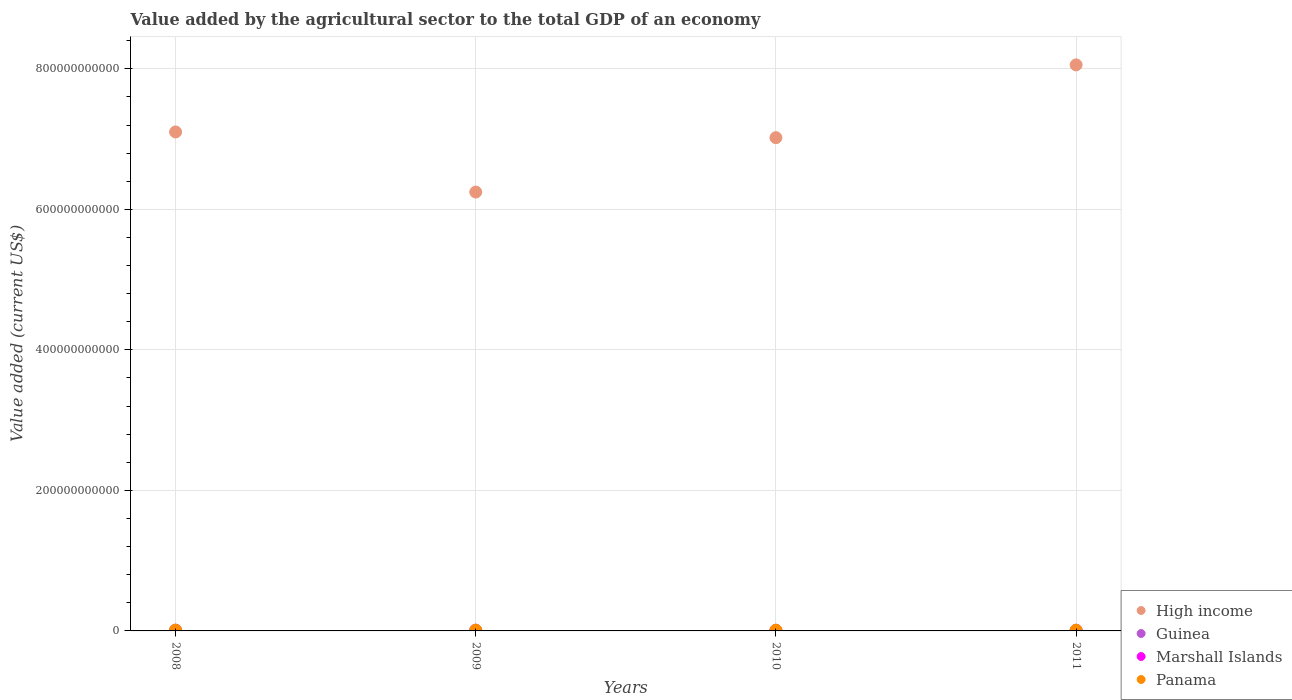Is the number of dotlines equal to the number of legend labels?
Provide a succinct answer. Yes. What is the value added by the agricultural sector to the total GDP in Marshall Islands in 2009?
Your response must be concise. 1.87e+07. Across all years, what is the maximum value added by the agricultural sector to the total GDP in Guinea?
Offer a very short reply. 1.09e+09. Across all years, what is the minimum value added by the agricultural sector to the total GDP in Panama?
Keep it short and to the point. 9.81e+08. What is the total value added by the agricultural sector to the total GDP in Marshall Islands in the graph?
Ensure brevity in your answer.  8.48e+07. What is the difference between the value added by the agricultural sector to the total GDP in Guinea in 2010 and that in 2011?
Give a very brief answer. -6.84e+07. What is the difference between the value added by the agricultural sector to the total GDP in Marshall Islands in 2011 and the value added by the agricultural sector to the total GDP in High income in 2010?
Keep it short and to the point. -7.02e+11. What is the average value added by the agricultural sector to the total GDP in Panama per year?
Provide a succinct answer. 1.04e+09. In the year 2008, what is the difference between the value added by the agricultural sector to the total GDP in Guinea and value added by the agricultural sector to the total GDP in Marshall Islands?
Your answer should be very brief. 1.01e+09. In how many years, is the value added by the agricultural sector to the total GDP in Marshall Islands greater than 560000000000 US$?
Your answer should be very brief. 0. What is the ratio of the value added by the agricultural sector to the total GDP in High income in 2008 to that in 2009?
Ensure brevity in your answer.  1.14. Is the value added by the agricultural sector to the total GDP in Marshall Islands in 2009 less than that in 2010?
Provide a succinct answer. Yes. What is the difference between the highest and the second highest value added by the agricultural sector to the total GDP in High income?
Provide a short and direct response. 9.55e+1. What is the difference between the highest and the lowest value added by the agricultural sector to the total GDP in High income?
Offer a very short reply. 1.81e+11. Is it the case that in every year, the sum of the value added by the agricultural sector to the total GDP in Marshall Islands and value added by the agricultural sector to the total GDP in Panama  is greater than the sum of value added by the agricultural sector to the total GDP in Guinea and value added by the agricultural sector to the total GDP in High income?
Your answer should be very brief. Yes. Is it the case that in every year, the sum of the value added by the agricultural sector to the total GDP in Guinea and value added by the agricultural sector to the total GDP in Panama  is greater than the value added by the agricultural sector to the total GDP in High income?
Offer a very short reply. No. How many dotlines are there?
Make the answer very short. 4. What is the difference between two consecutive major ticks on the Y-axis?
Your response must be concise. 2.00e+11. Are the values on the major ticks of Y-axis written in scientific E-notation?
Ensure brevity in your answer.  No. Does the graph contain any zero values?
Provide a short and direct response. No. Does the graph contain grids?
Offer a terse response. Yes. Where does the legend appear in the graph?
Your answer should be compact. Bottom right. How many legend labels are there?
Give a very brief answer. 4. What is the title of the graph?
Offer a terse response. Value added by the agricultural sector to the total GDP of an economy. What is the label or title of the X-axis?
Provide a succinct answer. Years. What is the label or title of the Y-axis?
Your response must be concise. Value added (current US$). What is the Value added (current US$) of High income in 2008?
Offer a terse response. 7.10e+11. What is the Value added (current US$) in Guinea in 2008?
Provide a short and direct response. 1.03e+09. What is the Value added (current US$) of Marshall Islands in 2008?
Your answer should be compact. 1.54e+07. What is the Value added (current US$) of Panama in 2008?
Offer a very short reply. 1.11e+09. What is the Value added (current US$) in High income in 2009?
Give a very brief answer. 6.25e+11. What is the Value added (current US$) of Guinea in 2009?
Offer a terse response. 1.09e+09. What is the Value added (current US$) in Marshall Islands in 2009?
Offer a very short reply. 1.87e+07. What is the Value added (current US$) of Panama in 2009?
Provide a short and direct response. 1.05e+09. What is the Value added (current US$) of High income in 2010?
Offer a very short reply. 7.02e+11. What is the Value added (current US$) in Guinea in 2010?
Provide a short and direct response. 9.59e+08. What is the Value added (current US$) of Marshall Islands in 2010?
Make the answer very short. 2.42e+07. What is the Value added (current US$) of Panama in 2010?
Provide a succinct answer. 9.81e+08. What is the Value added (current US$) in High income in 2011?
Keep it short and to the point. 8.06e+11. What is the Value added (current US$) in Guinea in 2011?
Provide a short and direct response. 1.03e+09. What is the Value added (current US$) of Marshall Islands in 2011?
Keep it short and to the point. 2.65e+07. What is the Value added (current US$) in Panama in 2011?
Provide a succinct answer. 1.01e+09. Across all years, what is the maximum Value added (current US$) in High income?
Keep it short and to the point. 8.06e+11. Across all years, what is the maximum Value added (current US$) in Guinea?
Your response must be concise. 1.09e+09. Across all years, what is the maximum Value added (current US$) in Marshall Islands?
Make the answer very short. 2.65e+07. Across all years, what is the maximum Value added (current US$) in Panama?
Ensure brevity in your answer.  1.11e+09. Across all years, what is the minimum Value added (current US$) of High income?
Keep it short and to the point. 6.25e+11. Across all years, what is the minimum Value added (current US$) in Guinea?
Make the answer very short. 9.59e+08. Across all years, what is the minimum Value added (current US$) in Marshall Islands?
Offer a very short reply. 1.54e+07. Across all years, what is the minimum Value added (current US$) of Panama?
Your response must be concise. 9.81e+08. What is the total Value added (current US$) of High income in the graph?
Your answer should be compact. 2.84e+12. What is the total Value added (current US$) in Guinea in the graph?
Make the answer very short. 4.11e+09. What is the total Value added (current US$) in Marshall Islands in the graph?
Your response must be concise. 8.48e+07. What is the total Value added (current US$) of Panama in the graph?
Your response must be concise. 4.15e+09. What is the difference between the Value added (current US$) in High income in 2008 and that in 2009?
Provide a succinct answer. 8.55e+1. What is the difference between the Value added (current US$) of Guinea in 2008 and that in 2009?
Give a very brief answer. -5.95e+07. What is the difference between the Value added (current US$) in Marshall Islands in 2008 and that in 2009?
Ensure brevity in your answer.  -3.39e+06. What is the difference between the Value added (current US$) in Panama in 2008 and that in 2009?
Keep it short and to the point. 5.31e+07. What is the difference between the Value added (current US$) of High income in 2008 and that in 2010?
Ensure brevity in your answer.  8.11e+09. What is the difference between the Value added (current US$) of Guinea in 2008 and that in 2010?
Give a very brief answer. 7.14e+07. What is the difference between the Value added (current US$) of Marshall Islands in 2008 and that in 2010?
Your response must be concise. -8.84e+06. What is the difference between the Value added (current US$) in Panama in 2008 and that in 2010?
Your answer should be very brief. 1.25e+08. What is the difference between the Value added (current US$) in High income in 2008 and that in 2011?
Offer a terse response. -9.55e+1. What is the difference between the Value added (current US$) in Guinea in 2008 and that in 2011?
Offer a terse response. 3.08e+06. What is the difference between the Value added (current US$) of Marshall Islands in 2008 and that in 2011?
Ensure brevity in your answer.  -1.11e+07. What is the difference between the Value added (current US$) of Panama in 2008 and that in 2011?
Your answer should be very brief. 9.89e+07. What is the difference between the Value added (current US$) of High income in 2009 and that in 2010?
Your answer should be compact. -7.74e+1. What is the difference between the Value added (current US$) in Guinea in 2009 and that in 2010?
Your response must be concise. 1.31e+08. What is the difference between the Value added (current US$) of Marshall Islands in 2009 and that in 2010?
Provide a short and direct response. -5.46e+06. What is the difference between the Value added (current US$) of Panama in 2009 and that in 2010?
Your response must be concise. 7.22e+07. What is the difference between the Value added (current US$) of High income in 2009 and that in 2011?
Provide a short and direct response. -1.81e+11. What is the difference between the Value added (current US$) in Guinea in 2009 and that in 2011?
Make the answer very short. 6.25e+07. What is the difference between the Value added (current US$) in Marshall Islands in 2009 and that in 2011?
Make the answer very short. -7.71e+06. What is the difference between the Value added (current US$) in Panama in 2009 and that in 2011?
Make the answer very short. 4.58e+07. What is the difference between the Value added (current US$) in High income in 2010 and that in 2011?
Give a very brief answer. -1.04e+11. What is the difference between the Value added (current US$) of Guinea in 2010 and that in 2011?
Provide a short and direct response. -6.84e+07. What is the difference between the Value added (current US$) in Marshall Islands in 2010 and that in 2011?
Provide a succinct answer. -2.25e+06. What is the difference between the Value added (current US$) in Panama in 2010 and that in 2011?
Give a very brief answer. -2.64e+07. What is the difference between the Value added (current US$) of High income in 2008 and the Value added (current US$) of Guinea in 2009?
Make the answer very short. 7.09e+11. What is the difference between the Value added (current US$) of High income in 2008 and the Value added (current US$) of Marshall Islands in 2009?
Make the answer very short. 7.10e+11. What is the difference between the Value added (current US$) of High income in 2008 and the Value added (current US$) of Panama in 2009?
Your answer should be compact. 7.09e+11. What is the difference between the Value added (current US$) in Guinea in 2008 and the Value added (current US$) in Marshall Islands in 2009?
Your response must be concise. 1.01e+09. What is the difference between the Value added (current US$) of Guinea in 2008 and the Value added (current US$) of Panama in 2009?
Your answer should be very brief. -2.32e+07. What is the difference between the Value added (current US$) of Marshall Islands in 2008 and the Value added (current US$) of Panama in 2009?
Your answer should be compact. -1.04e+09. What is the difference between the Value added (current US$) in High income in 2008 and the Value added (current US$) in Guinea in 2010?
Your response must be concise. 7.09e+11. What is the difference between the Value added (current US$) of High income in 2008 and the Value added (current US$) of Marshall Islands in 2010?
Make the answer very short. 7.10e+11. What is the difference between the Value added (current US$) of High income in 2008 and the Value added (current US$) of Panama in 2010?
Ensure brevity in your answer.  7.09e+11. What is the difference between the Value added (current US$) of Guinea in 2008 and the Value added (current US$) of Marshall Islands in 2010?
Make the answer very short. 1.01e+09. What is the difference between the Value added (current US$) of Guinea in 2008 and the Value added (current US$) of Panama in 2010?
Keep it short and to the point. 4.90e+07. What is the difference between the Value added (current US$) in Marshall Islands in 2008 and the Value added (current US$) in Panama in 2010?
Give a very brief answer. -9.66e+08. What is the difference between the Value added (current US$) of High income in 2008 and the Value added (current US$) of Guinea in 2011?
Provide a short and direct response. 7.09e+11. What is the difference between the Value added (current US$) in High income in 2008 and the Value added (current US$) in Marshall Islands in 2011?
Provide a succinct answer. 7.10e+11. What is the difference between the Value added (current US$) in High income in 2008 and the Value added (current US$) in Panama in 2011?
Provide a succinct answer. 7.09e+11. What is the difference between the Value added (current US$) in Guinea in 2008 and the Value added (current US$) in Marshall Islands in 2011?
Offer a very short reply. 1.00e+09. What is the difference between the Value added (current US$) in Guinea in 2008 and the Value added (current US$) in Panama in 2011?
Offer a terse response. 2.26e+07. What is the difference between the Value added (current US$) of Marshall Islands in 2008 and the Value added (current US$) of Panama in 2011?
Make the answer very short. -9.92e+08. What is the difference between the Value added (current US$) of High income in 2009 and the Value added (current US$) of Guinea in 2010?
Make the answer very short. 6.24e+11. What is the difference between the Value added (current US$) in High income in 2009 and the Value added (current US$) in Marshall Islands in 2010?
Your response must be concise. 6.25e+11. What is the difference between the Value added (current US$) in High income in 2009 and the Value added (current US$) in Panama in 2010?
Your response must be concise. 6.24e+11. What is the difference between the Value added (current US$) of Guinea in 2009 and the Value added (current US$) of Marshall Islands in 2010?
Ensure brevity in your answer.  1.07e+09. What is the difference between the Value added (current US$) of Guinea in 2009 and the Value added (current US$) of Panama in 2010?
Your answer should be very brief. 1.08e+08. What is the difference between the Value added (current US$) of Marshall Islands in 2009 and the Value added (current US$) of Panama in 2010?
Offer a very short reply. -9.63e+08. What is the difference between the Value added (current US$) in High income in 2009 and the Value added (current US$) in Guinea in 2011?
Ensure brevity in your answer.  6.24e+11. What is the difference between the Value added (current US$) of High income in 2009 and the Value added (current US$) of Marshall Islands in 2011?
Offer a very short reply. 6.25e+11. What is the difference between the Value added (current US$) in High income in 2009 and the Value added (current US$) in Panama in 2011?
Your answer should be very brief. 6.24e+11. What is the difference between the Value added (current US$) of Guinea in 2009 and the Value added (current US$) of Marshall Islands in 2011?
Ensure brevity in your answer.  1.06e+09. What is the difference between the Value added (current US$) in Guinea in 2009 and the Value added (current US$) in Panama in 2011?
Keep it short and to the point. 8.21e+07. What is the difference between the Value added (current US$) of Marshall Islands in 2009 and the Value added (current US$) of Panama in 2011?
Make the answer very short. -9.89e+08. What is the difference between the Value added (current US$) in High income in 2010 and the Value added (current US$) in Guinea in 2011?
Make the answer very short. 7.01e+11. What is the difference between the Value added (current US$) of High income in 2010 and the Value added (current US$) of Marshall Islands in 2011?
Make the answer very short. 7.02e+11. What is the difference between the Value added (current US$) of High income in 2010 and the Value added (current US$) of Panama in 2011?
Provide a succinct answer. 7.01e+11. What is the difference between the Value added (current US$) of Guinea in 2010 and the Value added (current US$) of Marshall Islands in 2011?
Offer a terse response. 9.32e+08. What is the difference between the Value added (current US$) in Guinea in 2010 and the Value added (current US$) in Panama in 2011?
Ensure brevity in your answer.  -4.88e+07. What is the difference between the Value added (current US$) of Marshall Islands in 2010 and the Value added (current US$) of Panama in 2011?
Offer a terse response. -9.83e+08. What is the average Value added (current US$) of High income per year?
Make the answer very short. 7.11e+11. What is the average Value added (current US$) in Guinea per year?
Provide a succinct answer. 1.03e+09. What is the average Value added (current US$) in Marshall Islands per year?
Make the answer very short. 2.12e+07. What is the average Value added (current US$) in Panama per year?
Provide a succinct answer. 1.04e+09. In the year 2008, what is the difference between the Value added (current US$) in High income and Value added (current US$) in Guinea?
Your answer should be compact. 7.09e+11. In the year 2008, what is the difference between the Value added (current US$) of High income and Value added (current US$) of Marshall Islands?
Keep it short and to the point. 7.10e+11. In the year 2008, what is the difference between the Value added (current US$) in High income and Value added (current US$) in Panama?
Make the answer very short. 7.09e+11. In the year 2008, what is the difference between the Value added (current US$) in Guinea and Value added (current US$) in Marshall Islands?
Your answer should be very brief. 1.01e+09. In the year 2008, what is the difference between the Value added (current US$) in Guinea and Value added (current US$) in Panama?
Make the answer very short. -7.63e+07. In the year 2008, what is the difference between the Value added (current US$) in Marshall Islands and Value added (current US$) in Panama?
Keep it short and to the point. -1.09e+09. In the year 2009, what is the difference between the Value added (current US$) of High income and Value added (current US$) of Guinea?
Provide a short and direct response. 6.24e+11. In the year 2009, what is the difference between the Value added (current US$) of High income and Value added (current US$) of Marshall Islands?
Keep it short and to the point. 6.25e+11. In the year 2009, what is the difference between the Value added (current US$) in High income and Value added (current US$) in Panama?
Offer a terse response. 6.24e+11. In the year 2009, what is the difference between the Value added (current US$) of Guinea and Value added (current US$) of Marshall Islands?
Provide a short and direct response. 1.07e+09. In the year 2009, what is the difference between the Value added (current US$) in Guinea and Value added (current US$) in Panama?
Give a very brief answer. 3.63e+07. In the year 2009, what is the difference between the Value added (current US$) in Marshall Islands and Value added (current US$) in Panama?
Your answer should be very brief. -1.03e+09. In the year 2010, what is the difference between the Value added (current US$) in High income and Value added (current US$) in Guinea?
Offer a terse response. 7.01e+11. In the year 2010, what is the difference between the Value added (current US$) of High income and Value added (current US$) of Marshall Islands?
Ensure brevity in your answer.  7.02e+11. In the year 2010, what is the difference between the Value added (current US$) in High income and Value added (current US$) in Panama?
Provide a short and direct response. 7.01e+11. In the year 2010, what is the difference between the Value added (current US$) in Guinea and Value added (current US$) in Marshall Islands?
Keep it short and to the point. 9.35e+08. In the year 2010, what is the difference between the Value added (current US$) of Guinea and Value added (current US$) of Panama?
Your answer should be very brief. -2.24e+07. In the year 2010, what is the difference between the Value added (current US$) in Marshall Islands and Value added (current US$) in Panama?
Ensure brevity in your answer.  -9.57e+08. In the year 2011, what is the difference between the Value added (current US$) of High income and Value added (current US$) of Guinea?
Provide a succinct answer. 8.05e+11. In the year 2011, what is the difference between the Value added (current US$) in High income and Value added (current US$) in Marshall Islands?
Keep it short and to the point. 8.06e+11. In the year 2011, what is the difference between the Value added (current US$) in High income and Value added (current US$) in Panama?
Make the answer very short. 8.05e+11. In the year 2011, what is the difference between the Value added (current US$) in Guinea and Value added (current US$) in Marshall Islands?
Offer a very short reply. 1.00e+09. In the year 2011, what is the difference between the Value added (current US$) of Guinea and Value added (current US$) of Panama?
Your answer should be very brief. 1.95e+07. In the year 2011, what is the difference between the Value added (current US$) in Marshall Islands and Value added (current US$) in Panama?
Give a very brief answer. -9.81e+08. What is the ratio of the Value added (current US$) in High income in 2008 to that in 2009?
Make the answer very short. 1.14. What is the ratio of the Value added (current US$) of Guinea in 2008 to that in 2009?
Make the answer very short. 0.95. What is the ratio of the Value added (current US$) of Marshall Islands in 2008 to that in 2009?
Offer a very short reply. 0.82. What is the ratio of the Value added (current US$) in Panama in 2008 to that in 2009?
Your answer should be compact. 1.05. What is the ratio of the Value added (current US$) in High income in 2008 to that in 2010?
Your response must be concise. 1.01. What is the ratio of the Value added (current US$) of Guinea in 2008 to that in 2010?
Provide a succinct answer. 1.07. What is the ratio of the Value added (current US$) in Marshall Islands in 2008 to that in 2010?
Make the answer very short. 0.63. What is the ratio of the Value added (current US$) in Panama in 2008 to that in 2010?
Make the answer very short. 1.13. What is the ratio of the Value added (current US$) of High income in 2008 to that in 2011?
Offer a very short reply. 0.88. What is the ratio of the Value added (current US$) in Marshall Islands in 2008 to that in 2011?
Offer a very short reply. 0.58. What is the ratio of the Value added (current US$) of Panama in 2008 to that in 2011?
Offer a terse response. 1.1. What is the ratio of the Value added (current US$) in High income in 2009 to that in 2010?
Provide a succinct answer. 0.89. What is the ratio of the Value added (current US$) of Guinea in 2009 to that in 2010?
Your answer should be very brief. 1.14. What is the ratio of the Value added (current US$) in Marshall Islands in 2009 to that in 2010?
Keep it short and to the point. 0.77. What is the ratio of the Value added (current US$) in Panama in 2009 to that in 2010?
Ensure brevity in your answer.  1.07. What is the ratio of the Value added (current US$) in High income in 2009 to that in 2011?
Ensure brevity in your answer.  0.78. What is the ratio of the Value added (current US$) in Guinea in 2009 to that in 2011?
Make the answer very short. 1.06. What is the ratio of the Value added (current US$) of Marshall Islands in 2009 to that in 2011?
Provide a succinct answer. 0.71. What is the ratio of the Value added (current US$) of Panama in 2009 to that in 2011?
Make the answer very short. 1.05. What is the ratio of the Value added (current US$) in High income in 2010 to that in 2011?
Ensure brevity in your answer.  0.87. What is the ratio of the Value added (current US$) of Guinea in 2010 to that in 2011?
Give a very brief answer. 0.93. What is the ratio of the Value added (current US$) in Marshall Islands in 2010 to that in 2011?
Ensure brevity in your answer.  0.91. What is the ratio of the Value added (current US$) of Panama in 2010 to that in 2011?
Ensure brevity in your answer.  0.97. What is the difference between the highest and the second highest Value added (current US$) in High income?
Your response must be concise. 9.55e+1. What is the difference between the highest and the second highest Value added (current US$) of Guinea?
Provide a succinct answer. 5.95e+07. What is the difference between the highest and the second highest Value added (current US$) of Marshall Islands?
Your answer should be very brief. 2.25e+06. What is the difference between the highest and the second highest Value added (current US$) of Panama?
Keep it short and to the point. 5.31e+07. What is the difference between the highest and the lowest Value added (current US$) in High income?
Offer a terse response. 1.81e+11. What is the difference between the highest and the lowest Value added (current US$) of Guinea?
Keep it short and to the point. 1.31e+08. What is the difference between the highest and the lowest Value added (current US$) in Marshall Islands?
Make the answer very short. 1.11e+07. What is the difference between the highest and the lowest Value added (current US$) in Panama?
Ensure brevity in your answer.  1.25e+08. 